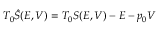<formula> <loc_0><loc_0><loc_500><loc_500>T _ { 0 } \hat { S } ( E , V ) = T _ { 0 } S ( E , V ) - E - p _ { 0 } V</formula> 